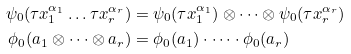Convert formula to latex. <formula><loc_0><loc_0><loc_500><loc_500>\psi _ { 0 } ( \tau x _ { 1 } ^ { \alpha _ { 1 } } \dots \tau x _ { r } ^ { \alpha _ { r } } ) & = \psi _ { 0 } ( \tau x _ { 1 } ^ { \alpha _ { 1 } } ) \otimes \dots \otimes \psi _ { 0 } ( \tau x _ { r } ^ { \alpha _ { r } } ) \\ \phi _ { 0 } ( a _ { 1 } \otimes \dots \otimes a _ { r } ) & = \phi _ { 0 } ( a _ { 1 } ) \cdot \dots \cdot \phi _ { 0 } ( a _ { r } )</formula> 